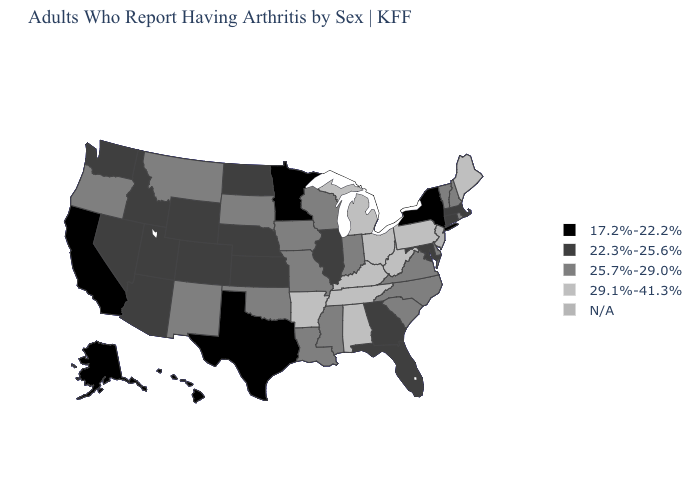What is the value of Georgia?
Answer briefly. 22.3%-25.6%. How many symbols are there in the legend?
Answer briefly. 5. What is the highest value in the USA?
Write a very short answer. 29.1%-41.3%. Name the states that have a value in the range 29.1%-41.3%?
Short answer required. Alabama, Arkansas, Kentucky, Maine, Michigan, Ohio, Pennsylvania, Tennessee, West Virginia. Is the legend a continuous bar?
Concise answer only. No. What is the value of Colorado?
Answer briefly. 22.3%-25.6%. What is the highest value in states that border Illinois?
Answer briefly. 29.1%-41.3%. What is the value of Georgia?
Keep it brief. 22.3%-25.6%. What is the highest value in states that border Michigan?
Answer briefly. 29.1%-41.3%. Which states hav the highest value in the West?
Be succinct. Montana, New Mexico, Oregon. Which states have the lowest value in the USA?
Concise answer only. Alaska, California, Hawaii, Minnesota, New York, Texas. Is the legend a continuous bar?
Write a very short answer. No. What is the value of South Dakota?
Answer briefly. 25.7%-29.0%. Does the map have missing data?
Give a very brief answer. Yes. How many symbols are there in the legend?
Short answer required. 5. 